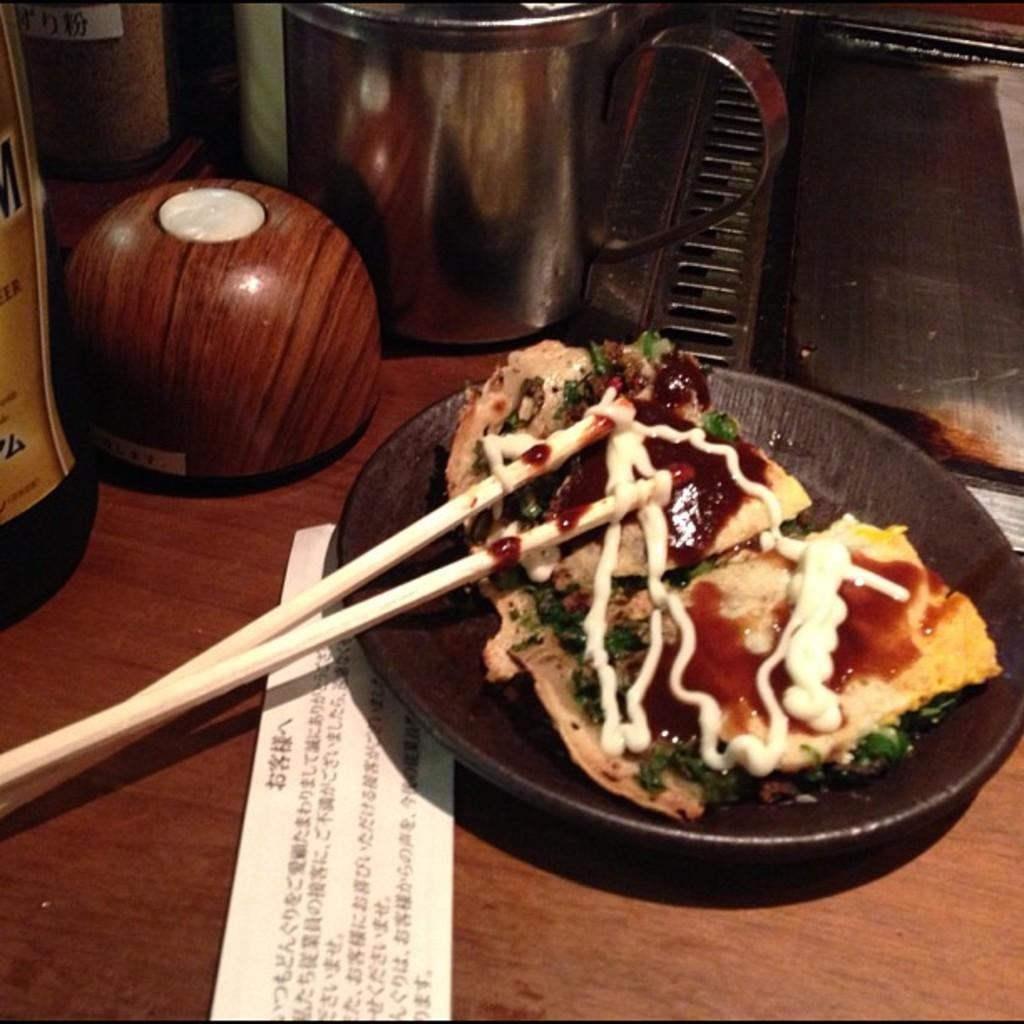What is the main subject of the image? There is a food item in the image. How is the food item presented? The food item is on a plate. What utensil is placed on top of the food item? There are chopsticks on top of the food item. Can you describe the background of the image? There are objects visible in the background of the image. What type of sheet is covering the plate in the image? There is no sheet present in the image; the food item is on a plate with chopsticks on top. 